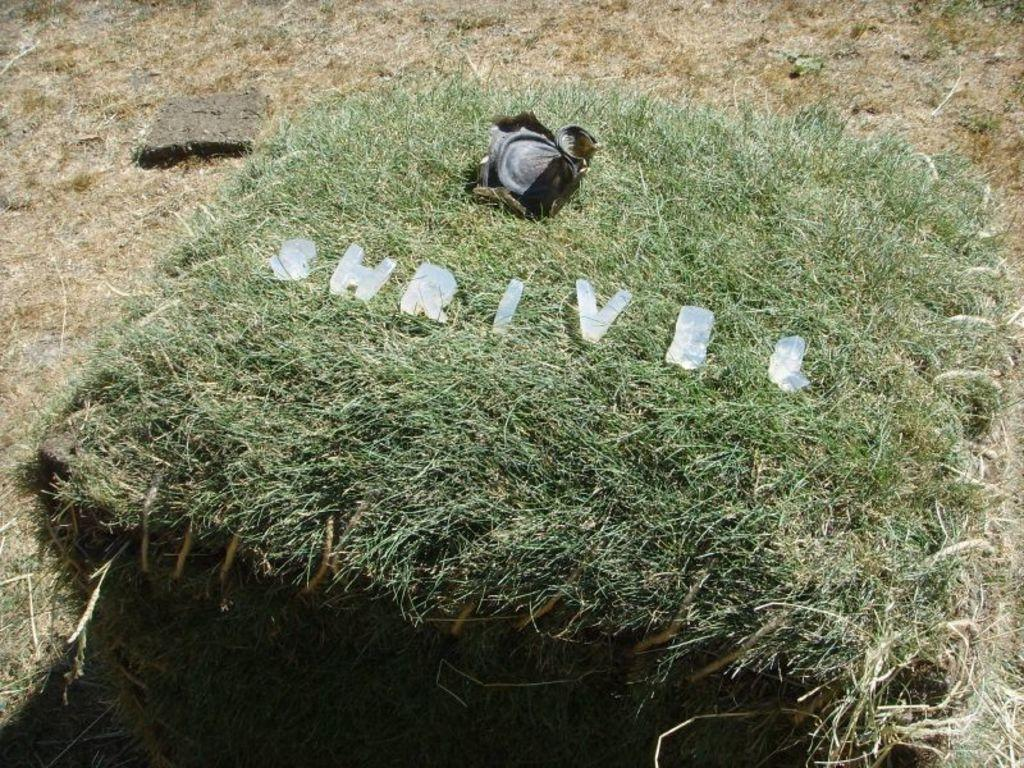What type of vegetation is present in the image? There is grass in the image. What can be seen on the grass in the image? There are alphabets on the grass. Is there a battle between giants taking place on the grass in the image? No, there is no battle or giants present in the image; it only features grass with alphabets on it. 